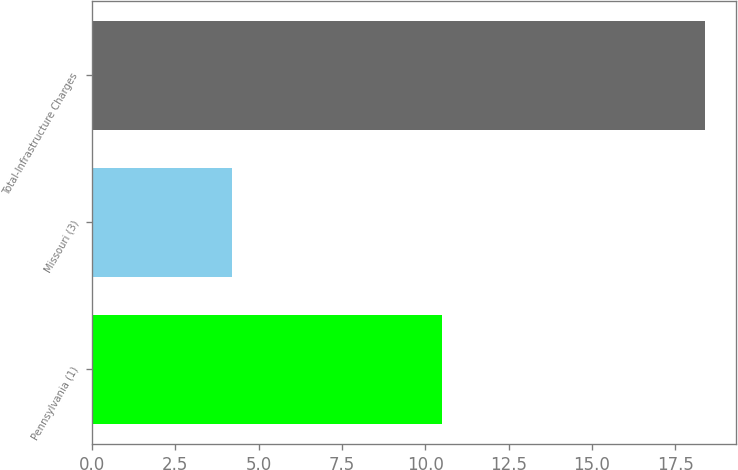Convert chart to OTSL. <chart><loc_0><loc_0><loc_500><loc_500><bar_chart><fcel>Pennsylvania (1)<fcel>Missouri (3)<fcel>Total-Infrastructure Charges<nl><fcel>10.5<fcel>4.2<fcel>18.4<nl></chart> 